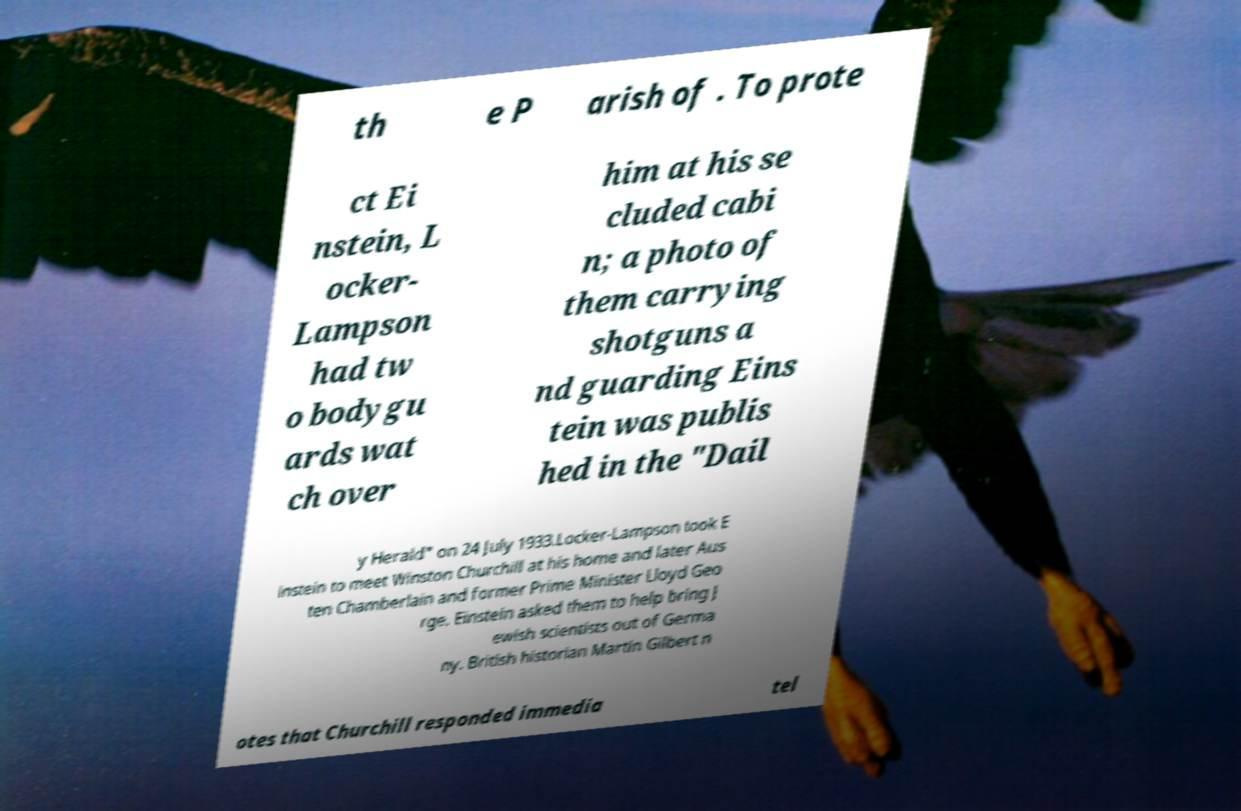Could you extract and type out the text from this image? th e P arish of . To prote ct Ei nstein, L ocker- Lampson had tw o bodygu ards wat ch over him at his se cluded cabi n; a photo of them carrying shotguns a nd guarding Eins tein was publis hed in the "Dail y Herald" on 24 July 1933.Locker-Lampson took E instein to meet Winston Churchill at his home and later Aus ten Chamberlain and former Prime Minister Lloyd Geo rge. Einstein asked them to help bring J ewish scientists out of Germa ny. British historian Martin Gilbert n otes that Churchill responded immedia tel 